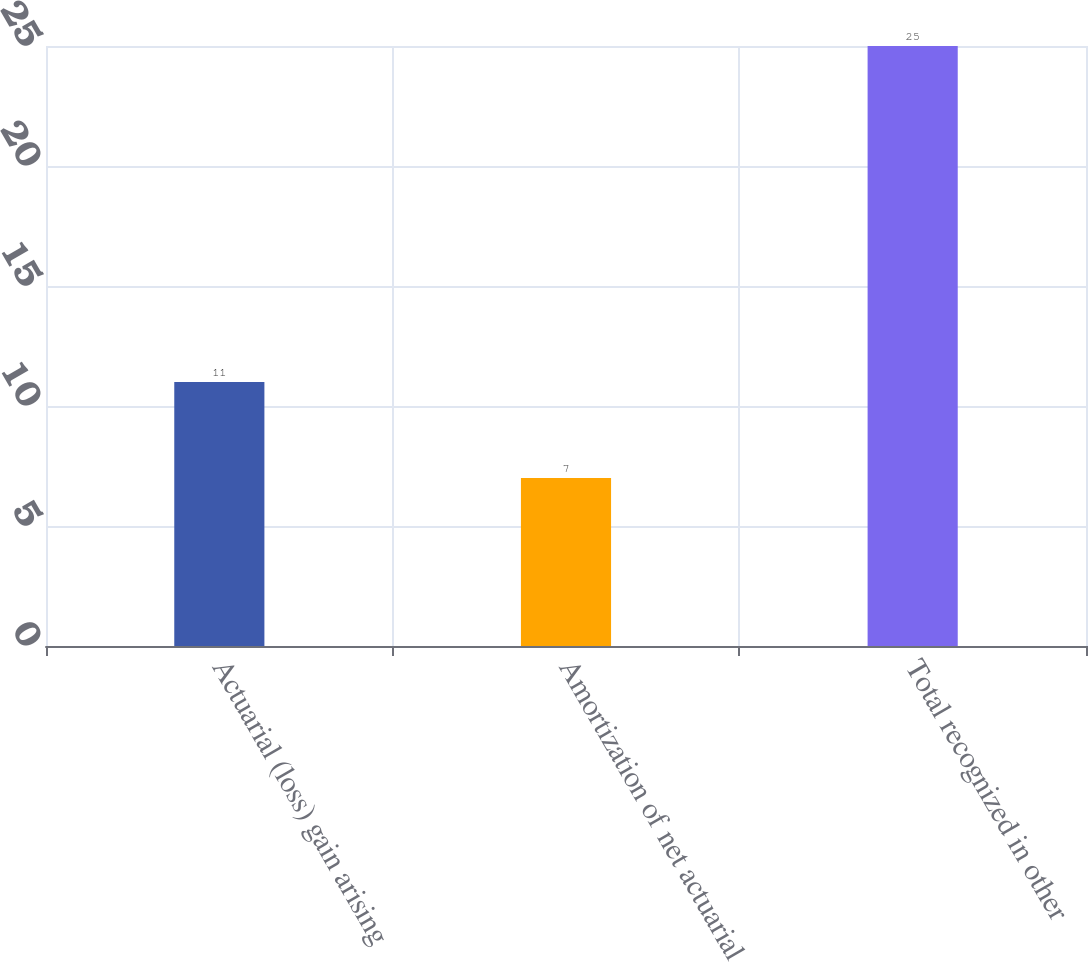Convert chart to OTSL. <chart><loc_0><loc_0><loc_500><loc_500><bar_chart><fcel>Actuarial (loss) gain arising<fcel>Amortization of net actuarial<fcel>Total recognized in other<nl><fcel>11<fcel>7<fcel>25<nl></chart> 